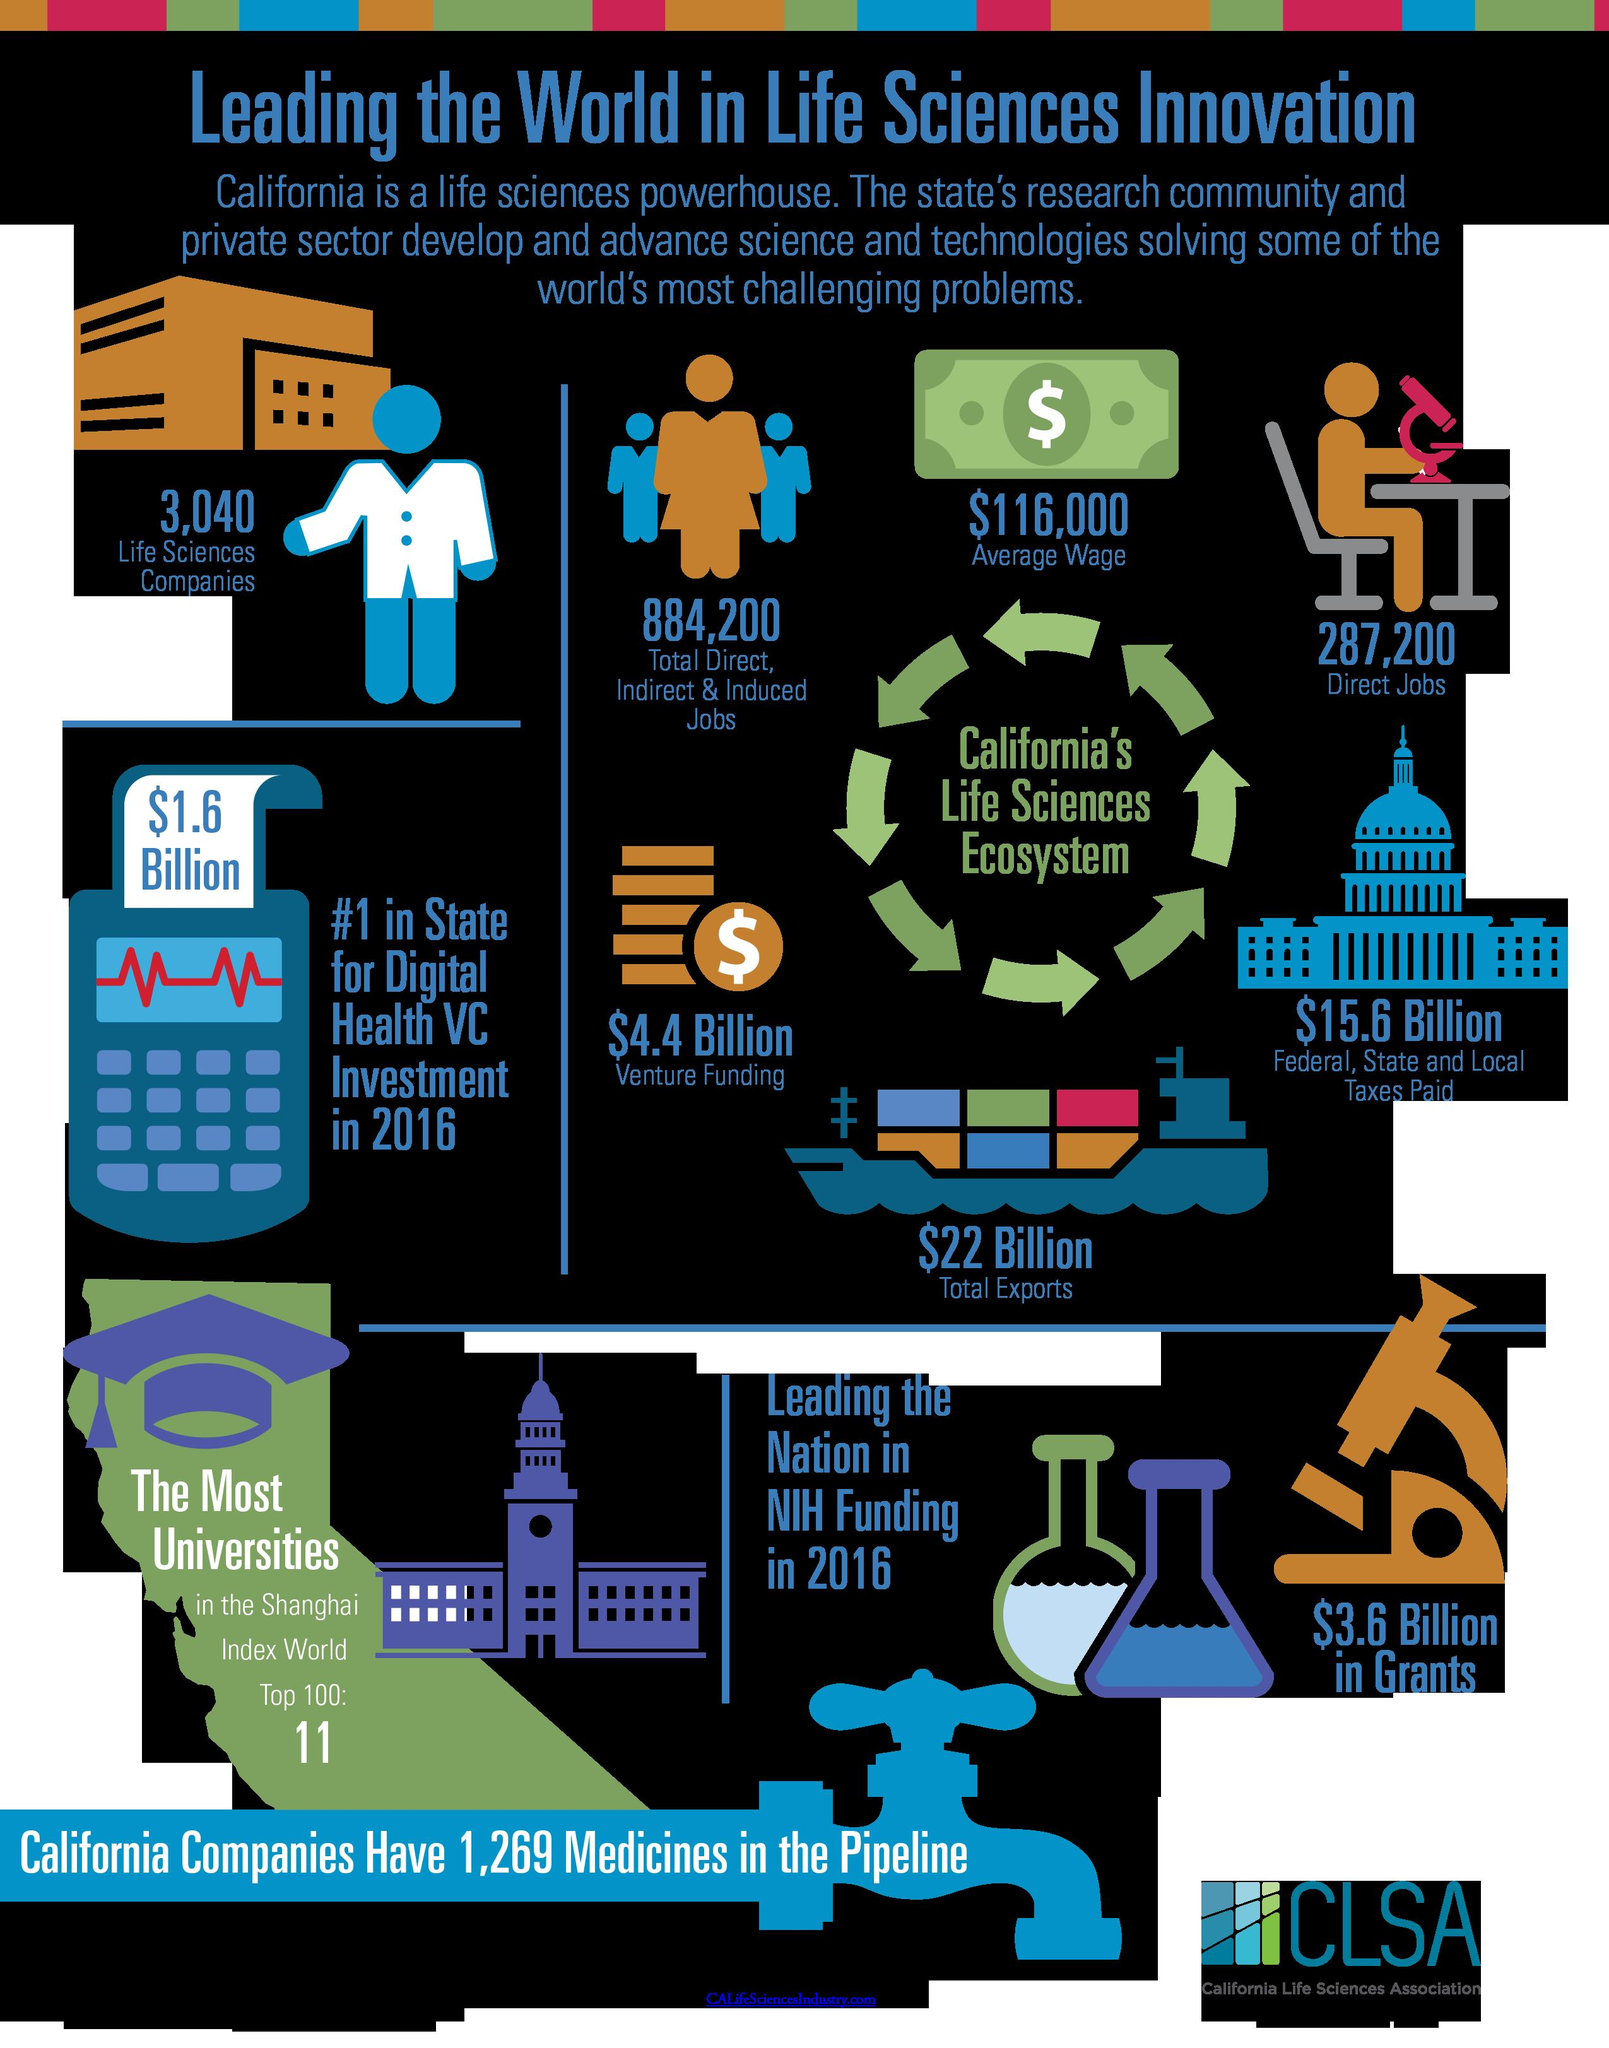List a handful of essential elements in this visual. In 2016, the amount of venture capital investment in the field of digital health was $1.6 billion. There are approximately 3,040 Life Sciences companies located in California. According to the microscope, there are 43.6 billion dollars in grants available. California's Life Sciences Ecosystem supports 287,200 direct jobs. According to recent data, the average wage in the life sciences industry is estimated to be $116,000 per year. 